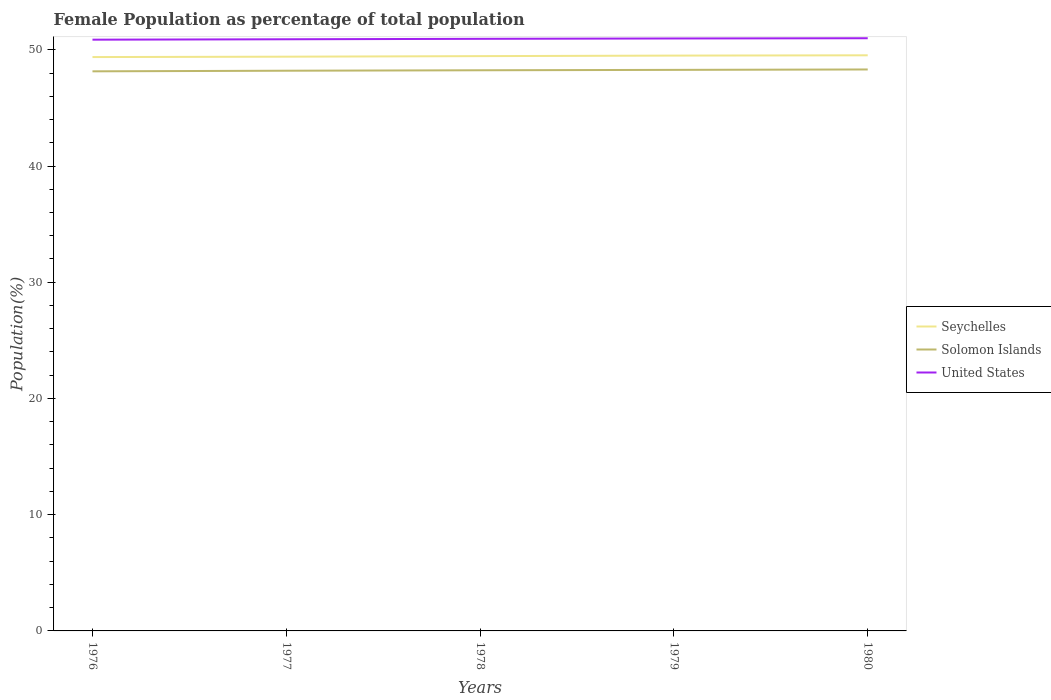How many different coloured lines are there?
Ensure brevity in your answer.  3. Across all years, what is the maximum female population in in Solomon Islands?
Keep it short and to the point. 48.15. In which year was the female population in in Seychelles maximum?
Provide a succinct answer. 1976. What is the total female population in in United States in the graph?
Your answer should be compact. -0.1. What is the difference between the highest and the second highest female population in in Seychelles?
Ensure brevity in your answer.  0.15. What is the difference between the highest and the lowest female population in in Seychelles?
Provide a succinct answer. 3. Is the female population in in United States strictly greater than the female population in in Seychelles over the years?
Your answer should be very brief. No. How many lines are there?
Give a very brief answer. 3. How many years are there in the graph?
Provide a short and direct response. 5. What is the difference between two consecutive major ticks on the Y-axis?
Ensure brevity in your answer.  10. Does the graph contain any zero values?
Keep it short and to the point. No. Where does the legend appear in the graph?
Provide a succinct answer. Center right. What is the title of the graph?
Give a very brief answer. Female Population as percentage of total population. Does "China" appear as one of the legend labels in the graph?
Offer a terse response. No. What is the label or title of the X-axis?
Offer a terse response. Years. What is the label or title of the Y-axis?
Ensure brevity in your answer.  Population(%). What is the Population(%) in Seychelles in 1976?
Offer a terse response. 49.37. What is the Population(%) of Solomon Islands in 1976?
Your response must be concise. 48.15. What is the Population(%) in United States in 1976?
Offer a very short reply. 50.87. What is the Population(%) in Seychelles in 1977?
Ensure brevity in your answer.  49.4. What is the Population(%) of Solomon Islands in 1977?
Your answer should be very brief. 48.2. What is the Population(%) of United States in 1977?
Ensure brevity in your answer.  50.9. What is the Population(%) in Seychelles in 1978?
Provide a short and direct response. 49.45. What is the Population(%) in Solomon Islands in 1978?
Your answer should be very brief. 48.24. What is the Population(%) of United States in 1978?
Ensure brevity in your answer.  50.94. What is the Population(%) of Seychelles in 1979?
Your response must be concise. 49.5. What is the Population(%) in Solomon Islands in 1979?
Provide a succinct answer. 48.27. What is the Population(%) in United States in 1979?
Make the answer very short. 50.97. What is the Population(%) of Seychelles in 1980?
Your answer should be very brief. 49.52. What is the Population(%) in Solomon Islands in 1980?
Provide a short and direct response. 48.31. What is the Population(%) of United States in 1980?
Provide a succinct answer. 50.99. Across all years, what is the maximum Population(%) of Seychelles?
Give a very brief answer. 49.52. Across all years, what is the maximum Population(%) of Solomon Islands?
Ensure brevity in your answer.  48.31. Across all years, what is the maximum Population(%) of United States?
Give a very brief answer. 50.99. Across all years, what is the minimum Population(%) in Seychelles?
Offer a terse response. 49.37. Across all years, what is the minimum Population(%) in Solomon Islands?
Your answer should be compact. 48.15. Across all years, what is the minimum Population(%) of United States?
Make the answer very short. 50.87. What is the total Population(%) in Seychelles in the graph?
Ensure brevity in your answer.  247.25. What is the total Population(%) of Solomon Islands in the graph?
Provide a short and direct response. 241.16. What is the total Population(%) in United States in the graph?
Your response must be concise. 254.68. What is the difference between the Population(%) of Seychelles in 1976 and that in 1977?
Keep it short and to the point. -0.03. What is the difference between the Population(%) of Solomon Islands in 1976 and that in 1977?
Offer a very short reply. -0.05. What is the difference between the Population(%) of United States in 1976 and that in 1977?
Provide a short and direct response. -0.04. What is the difference between the Population(%) of Seychelles in 1976 and that in 1978?
Ensure brevity in your answer.  -0.08. What is the difference between the Population(%) in Solomon Islands in 1976 and that in 1978?
Provide a short and direct response. -0.09. What is the difference between the Population(%) of United States in 1976 and that in 1978?
Ensure brevity in your answer.  -0.07. What is the difference between the Population(%) of Seychelles in 1976 and that in 1979?
Provide a succinct answer. -0.13. What is the difference between the Population(%) of Solomon Islands in 1976 and that in 1979?
Your answer should be compact. -0.13. What is the difference between the Population(%) in United States in 1976 and that in 1979?
Provide a succinct answer. -0.1. What is the difference between the Population(%) of Seychelles in 1976 and that in 1980?
Ensure brevity in your answer.  -0.15. What is the difference between the Population(%) in Solomon Islands in 1976 and that in 1980?
Give a very brief answer. -0.16. What is the difference between the Population(%) of United States in 1976 and that in 1980?
Your response must be concise. -0.12. What is the difference between the Population(%) of Seychelles in 1977 and that in 1978?
Keep it short and to the point. -0.05. What is the difference between the Population(%) of Solomon Islands in 1977 and that in 1978?
Give a very brief answer. -0.04. What is the difference between the Population(%) of United States in 1977 and that in 1978?
Offer a very short reply. -0.04. What is the difference between the Population(%) in Seychelles in 1977 and that in 1979?
Provide a succinct answer. -0.09. What is the difference between the Population(%) of Solomon Islands in 1977 and that in 1979?
Your answer should be compact. -0.07. What is the difference between the Population(%) in United States in 1977 and that in 1979?
Offer a terse response. -0.07. What is the difference between the Population(%) in Seychelles in 1977 and that in 1980?
Keep it short and to the point. -0.12. What is the difference between the Population(%) in Solomon Islands in 1977 and that in 1980?
Keep it short and to the point. -0.11. What is the difference between the Population(%) of United States in 1977 and that in 1980?
Give a very brief answer. -0.09. What is the difference between the Population(%) of Seychelles in 1978 and that in 1979?
Offer a terse response. -0.05. What is the difference between the Population(%) of Solomon Islands in 1978 and that in 1979?
Your answer should be very brief. -0.03. What is the difference between the Population(%) of United States in 1978 and that in 1979?
Your response must be concise. -0.03. What is the difference between the Population(%) in Seychelles in 1978 and that in 1980?
Offer a terse response. -0.07. What is the difference between the Population(%) in Solomon Islands in 1978 and that in 1980?
Your answer should be compact. -0.07. What is the difference between the Population(%) in United States in 1978 and that in 1980?
Keep it short and to the point. -0.05. What is the difference between the Population(%) of Seychelles in 1979 and that in 1980?
Offer a very short reply. -0.03. What is the difference between the Population(%) of Solomon Islands in 1979 and that in 1980?
Offer a very short reply. -0.03. What is the difference between the Population(%) of United States in 1979 and that in 1980?
Give a very brief answer. -0.02. What is the difference between the Population(%) of Seychelles in 1976 and the Population(%) of Solomon Islands in 1977?
Your answer should be compact. 1.17. What is the difference between the Population(%) of Seychelles in 1976 and the Population(%) of United States in 1977?
Your answer should be very brief. -1.53. What is the difference between the Population(%) of Solomon Islands in 1976 and the Population(%) of United States in 1977?
Offer a very short reply. -2.76. What is the difference between the Population(%) of Seychelles in 1976 and the Population(%) of Solomon Islands in 1978?
Your response must be concise. 1.14. What is the difference between the Population(%) in Seychelles in 1976 and the Population(%) in United States in 1978?
Keep it short and to the point. -1.57. What is the difference between the Population(%) in Solomon Islands in 1976 and the Population(%) in United States in 1978?
Provide a short and direct response. -2.8. What is the difference between the Population(%) of Seychelles in 1976 and the Population(%) of Solomon Islands in 1979?
Offer a very short reply. 1.1. What is the difference between the Population(%) of Seychelles in 1976 and the Population(%) of United States in 1979?
Ensure brevity in your answer.  -1.6. What is the difference between the Population(%) in Solomon Islands in 1976 and the Population(%) in United States in 1979?
Your answer should be very brief. -2.83. What is the difference between the Population(%) in Seychelles in 1976 and the Population(%) in Solomon Islands in 1980?
Your response must be concise. 1.07. What is the difference between the Population(%) in Seychelles in 1976 and the Population(%) in United States in 1980?
Provide a short and direct response. -1.62. What is the difference between the Population(%) in Solomon Islands in 1976 and the Population(%) in United States in 1980?
Your answer should be very brief. -2.85. What is the difference between the Population(%) in Seychelles in 1977 and the Population(%) in Solomon Islands in 1978?
Keep it short and to the point. 1.17. What is the difference between the Population(%) of Seychelles in 1977 and the Population(%) of United States in 1978?
Your answer should be very brief. -1.54. What is the difference between the Population(%) of Solomon Islands in 1977 and the Population(%) of United States in 1978?
Provide a succinct answer. -2.74. What is the difference between the Population(%) of Seychelles in 1977 and the Population(%) of Solomon Islands in 1979?
Provide a succinct answer. 1.13. What is the difference between the Population(%) in Seychelles in 1977 and the Population(%) in United States in 1979?
Make the answer very short. -1.57. What is the difference between the Population(%) in Solomon Islands in 1977 and the Population(%) in United States in 1979?
Your response must be concise. -2.77. What is the difference between the Population(%) of Seychelles in 1977 and the Population(%) of Solomon Islands in 1980?
Give a very brief answer. 1.1. What is the difference between the Population(%) of Seychelles in 1977 and the Population(%) of United States in 1980?
Your answer should be compact. -1.59. What is the difference between the Population(%) of Solomon Islands in 1977 and the Population(%) of United States in 1980?
Make the answer very short. -2.79. What is the difference between the Population(%) of Seychelles in 1978 and the Population(%) of Solomon Islands in 1979?
Give a very brief answer. 1.18. What is the difference between the Population(%) of Seychelles in 1978 and the Population(%) of United States in 1979?
Your answer should be compact. -1.52. What is the difference between the Population(%) in Solomon Islands in 1978 and the Population(%) in United States in 1979?
Your response must be concise. -2.73. What is the difference between the Population(%) in Seychelles in 1978 and the Population(%) in Solomon Islands in 1980?
Give a very brief answer. 1.15. What is the difference between the Population(%) in Seychelles in 1978 and the Population(%) in United States in 1980?
Your answer should be very brief. -1.54. What is the difference between the Population(%) in Solomon Islands in 1978 and the Population(%) in United States in 1980?
Keep it short and to the point. -2.76. What is the difference between the Population(%) of Seychelles in 1979 and the Population(%) of Solomon Islands in 1980?
Give a very brief answer. 1.19. What is the difference between the Population(%) in Seychelles in 1979 and the Population(%) in United States in 1980?
Keep it short and to the point. -1.49. What is the difference between the Population(%) of Solomon Islands in 1979 and the Population(%) of United States in 1980?
Your response must be concise. -2.72. What is the average Population(%) of Seychelles per year?
Give a very brief answer. 49.45. What is the average Population(%) in Solomon Islands per year?
Offer a very short reply. 48.23. What is the average Population(%) in United States per year?
Offer a very short reply. 50.94. In the year 1976, what is the difference between the Population(%) in Seychelles and Population(%) in Solomon Islands?
Provide a short and direct response. 1.23. In the year 1976, what is the difference between the Population(%) in Seychelles and Population(%) in United States?
Offer a very short reply. -1.5. In the year 1976, what is the difference between the Population(%) in Solomon Islands and Population(%) in United States?
Keep it short and to the point. -2.72. In the year 1977, what is the difference between the Population(%) in Seychelles and Population(%) in Solomon Islands?
Your response must be concise. 1.21. In the year 1977, what is the difference between the Population(%) of Solomon Islands and Population(%) of United States?
Offer a very short reply. -2.71. In the year 1978, what is the difference between the Population(%) of Seychelles and Population(%) of Solomon Islands?
Offer a terse response. 1.22. In the year 1978, what is the difference between the Population(%) of Seychelles and Population(%) of United States?
Your answer should be compact. -1.49. In the year 1978, what is the difference between the Population(%) in Solomon Islands and Population(%) in United States?
Provide a short and direct response. -2.7. In the year 1979, what is the difference between the Population(%) of Seychelles and Population(%) of Solomon Islands?
Make the answer very short. 1.23. In the year 1979, what is the difference between the Population(%) of Seychelles and Population(%) of United States?
Give a very brief answer. -1.47. In the year 1979, what is the difference between the Population(%) in Solomon Islands and Population(%) in United States?
Your answer should be very brief. -2.7. In the year 1980, what is the difference between the Population(%) in Seychelles and Population(%) in Solomon Islands?
Offer a terse response. 1.22. In the year 1980, what is the difference between the Population(%) of Seychelles and Population(%) of United States?
Your answer should be compact. -1.47. In the year 1980, what is the difference between the Population(%) in Solomon Islands and Population(%) in United States?
Your answer should be compact. -2.69. What is the ratio of the Population(%) in Solomon Islands in 1976 to that in 1977?
Provide a short and direct response. 1. What is the ratio of the Population(%) in Seychelles in 1976 to that in 1978?
Provide a succinct answer. 1. What is the ratio of the Population(%) in Solomon Islands in 1976 to that in 1978?
Your response must be concise. 1. What is the ratio of the Population(%) of Seychelles in 1976 to that in 1979?
Keep it short and to the point. 1. What is the ratio of the Population(%) in United States in 1976 to that in 1979?
Ensure brevity in your answer.  1. What is the ratio of the Population(%) of Seychelles in 1976 to that in 1980?
Your response must be concise. 1. What is the ratio of the Population(%) in Solomon Islands in 1976 to that in 1980?
Make the answer very short. 1. What is the ratio of the Population(%) in United States in 1977 to that in 1978?
Provide a succinct answer. 1. What is the ratio of the Population(%) in Seychelles in 1977 to that in 1979?
Your answer should be compact. 1. What is the ratio of the Population(%) of Solomon Islands in 1977 to that in 1980?
Your answer should be very brief. 1. What is the ratio of the Population(%) of Seychelles in 1978 to that in 1980?
Provide a short and direct response. 1. What is the ratio of the Population(%) of Solomon Islands in 1978 to that in 1980?
Ensure brevity in your answer.  1. What is the difference between the highest and the second highest Population(%) of Seychelles?
Ensure brevity in your answer.  0.03. What is the difference between the highest and the second highest Population(%) of Solomon Islands?
Offer a very short reply. 0.03. What is the difference between the highest and the second highest Population(%) of United States?
Offer a terse response. 0.02. What is the difference between the highest and the lowest Population(%) in Seychelles?
Your response must be concise. 0.15. What is the difference between the highest and the lowest Population(%) of Solomon Islands?
Your response must be concise. 0.16. What is the difference between the highest and the lowest Population(%) in United States?
Provide a short and direct response. 0.12. 